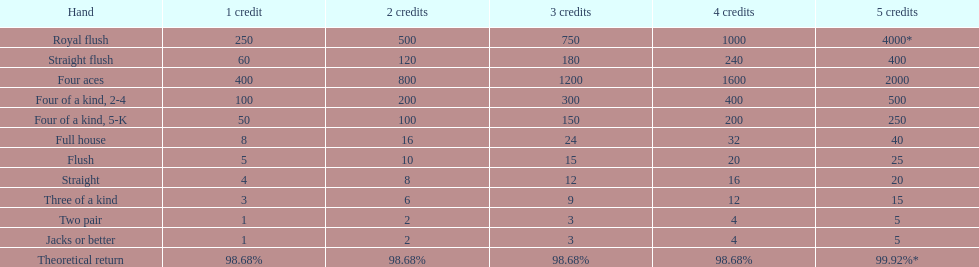Is a 2 credit full house the same as a 5 credit three of a kind? No. 